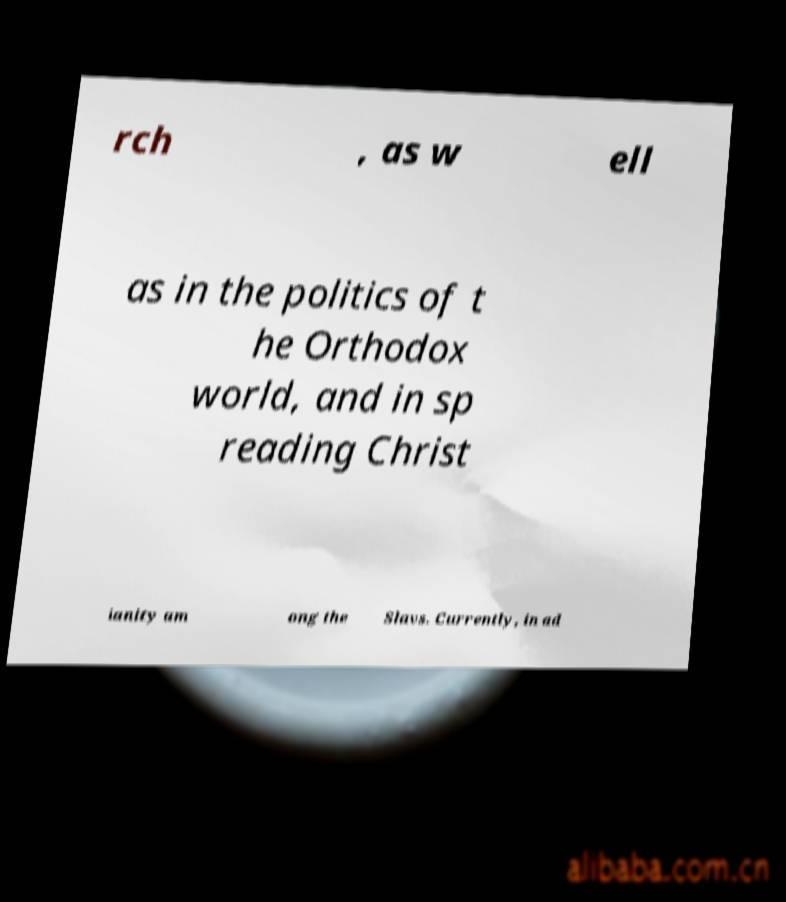Please identify and transcribe the text found in this image. rch , as w ell as in the politics of t he Orthodox world, and in sp reading Christ ianity am ong the Slavs. Currently, in ad 